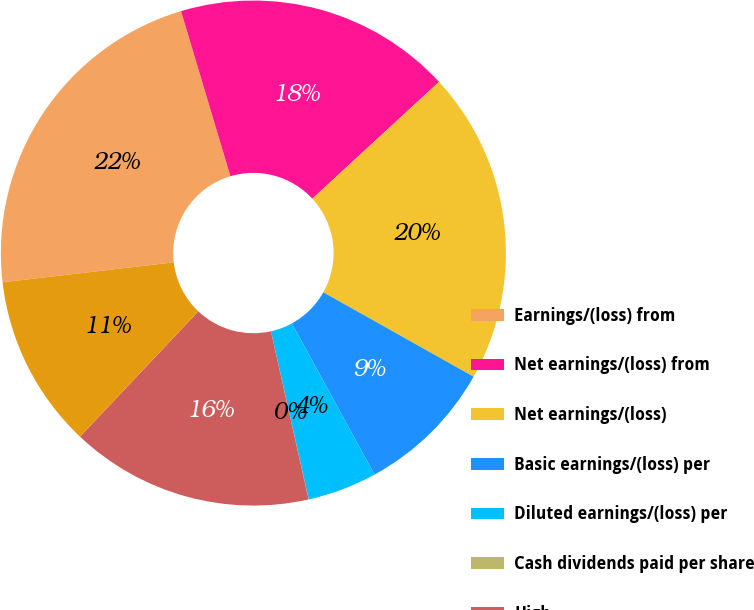Convert chart to OTSL. <chart><loc_0><loc_0><loc_500><loc_500><pie_chart><fcel>Earnings/(loss) from<fcel>Net earnings/(loss) from<fcel>Net earnings/(loss)<fcel>Basic earnings/(loss) per<fcel>Diluted earnings/(loss) per<fcel>Cash dividends paid per share<fcel>High<fcel>Low<nl><fcel>22.22%<fcel>17.77%<fcel>20.0%<fcel>8.89%<fcel>4.45%<fcel>0.01%<fcel>15.55%<fcel>11.11%<nl></chart> 